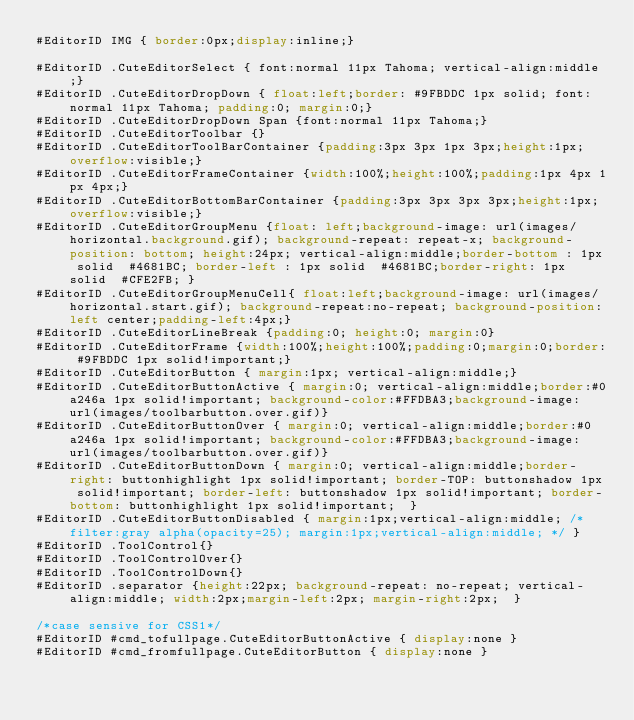<code> <loc_0><loc_0><loc_500><loc_500><_CSS_>#EditorID IMG { border:0px;display:inline;}

#EditorID .CuteEditorSelect { font:normal 11px Tahoma; vertical-align:middle;}
#EditorID .CuteEditorDropDown { float:left;border: #9FBDDC 1px solid; font:normal 11px Tahoma; padding:0; margin:0;}
#EditorID .CuteEditorDropDown Span {font:normal 11px Tahoma;}
#EditorID .CuteEditorToolbar {}
#EditorID .CuteEditorToolBarContainer {padding:3px 3px 1px 3px;height:1px;overflow:visible;}
#EditorID .CuteEditorFrameContainer {width:100%;height:100%;padding:1px 4px 1px 4px;}
#EditorID .CuteEditorBottomBarContainer {padding:3px 3px 3px 3px;height:1px;overflow:visible;}
#EditorID .CuteEditorGroupMenu {float: left;background-image: url(images/horizontal.background.gif); background-repeat: repeat-x; background-position: bottom; height:24px; vertical-align:middle;border-bottom : 1px solid  #4681BC; border-left : 1px solid  #4681BC;border-right: 1px solid  #CFE2FB; }
#EditorID .CuteEditorGroupMenuCell{ float:left;background-image: url(images/horizontal.start.gif); background-repeat:no-repeat; background-position:left center;padding-left:4px;}
#EditorID .CuteEditorLineBreak {padding:0; height:0; margin:0}
#EditorID .CuteEditorFrame {width:100%;height:100%;padding:0;margin:0;border: #9FBDDC 1px solid!important;}
#EditorID .CuteEditorButton { margin:1px; vertical-align:middle;}
#EditorID .CuteEditorButtonActive { margin:0; vertical-align:middle;border:#0a246a 1px solid!important; background-color:#FFDBA3;background-image: url(images/toolbarbutton.over.gif)}
#EditorID .CuteEditorButtonOver { margin:0; vertical-align:middle;border:#0a246a 1px solid!important; background-color:#FFDBA3;background-image: url(images/toolbarbutton.over.gif)}
#EditorID .CuteEditorButtonDown { margin:0; vertical-align:middle;border-right: buttonhighlight 1px solid!important; border-TOP: buttonshadow 1px solid!important; border-left: buttonshadow 1px solid!important; border-bottom: buttonhighlight 1px solid!important;  }
#EditorID .CuteEditorButtonDisabled { margin:1px;vertical-align:middle; /* filter:gray alpha(opacity=25); margin:1px;vertical-align:middle; */ }
#EditorID .ToolControl{}
#EditorID .ToolControlOver{}
#EditorID .ToolControlDown{}
#EditorID .separator {height:22px; background-repeat: no-repeat; vertical-align:middle; width:2px;margin-left:2px; margin-right:2px;	}

/*case sensive for CSS1*/
#EditorID #cmd_tofullpage.CuteEditorButtonActive { display:none }
#EditorID #cmd_fromfullpage.CuteEditorButton { display:none }
</code> 